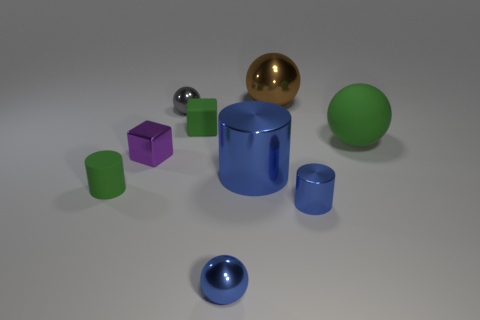There is a small purple metallic object; what shape is it?
Offer a very short reply. Cube. There is a green block; what number of gray shiny objects are on the left side of it?
Your answer should be very brief. 1. How many big cylinders are made of the same material as the gray thing?
Provide a short and direct response. 1. Does the tiny thing that is to the right of the blue shiny ball have the same material as the large cylinder?
Your answer should be compact. Yes. Is there a small cube?
Offer a terse response. Yes. How big is the green thing that is both left of the brown ball and on the right side of the metal block?
Make the answer very short. Small. Is the number of shiny blocks behind the brown object greater than the number of things that are behind the blue sphere?
Offer a very short reply. No. What size is the rubber cylinder that is the same color as the large rubber sphere?
Keep it short and to the point. Small. The rubber block is what color?
Offer a terse response. Green. There is a metal thing that is to the left of the small blue shiny sphere and in front of the green matte sphere; what color is it?
Make the answer very short. Purple. 